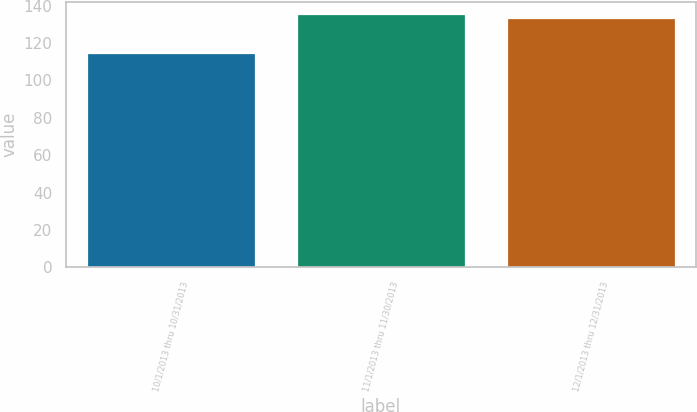Convert chart. <chart><loc_0><loc_0><loc_500><loc_500><bar_chart><fcel>10/1/2013 thru 10/31/2013<fcel>11/1/2013 thru 11/30/2013<fcel>12/1/2013 thru 12/31/2013<nl><fcel>114.75<fcel>135.24<fcel>133.31<nl></chart> 